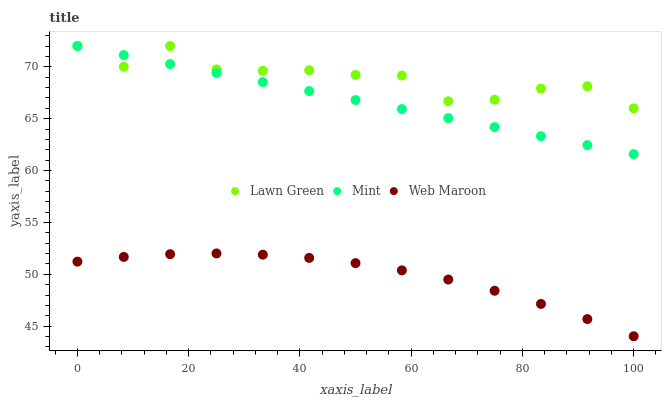Does Web Maroon have the minimum area under the curve?
Answer yes or no. Yes. Does Lawn Green have the maximum area under the curve?
Answer yes or no. Yes. Does Mint have the minimum area under the curve?
Answer yes or no. No. Does Mint have the maximum area under the curve?
Answer yes or no. No. Is Mint the smoothest?
Answer yes or no. Yes. Is Lawn Green the roughest?
Answer yes or no. Yes. Is Web Maroon the smoothest?
Answer yes or no. No. Is Web Maroon the roughest?
Answer yes or no. No. Does Web Maroon have the lowest value?
Answer yes or no. Yes. Does Mint have the lowest value?
Answer yes or no. No. Does Mint have the highest value?
Answer yes or no. Yes. Does Web Maroon have the highest value?
Answer yes or no. No. Is Web Maroon less than Mint?
Answer yes or no. Yes. Is Lawn Green greater than Web Maroon?
Answer yes or no. Yes. Does Lawn Green intersect Mint?
Answer yes or no. Yes. Is Lawn Green less than Mint?
Answer yes or no. No. Is Lawn Green greater than Mint?
Answer yes or no. No. Does Web Maroon intersect Mint?
Answer yes or no. No. 